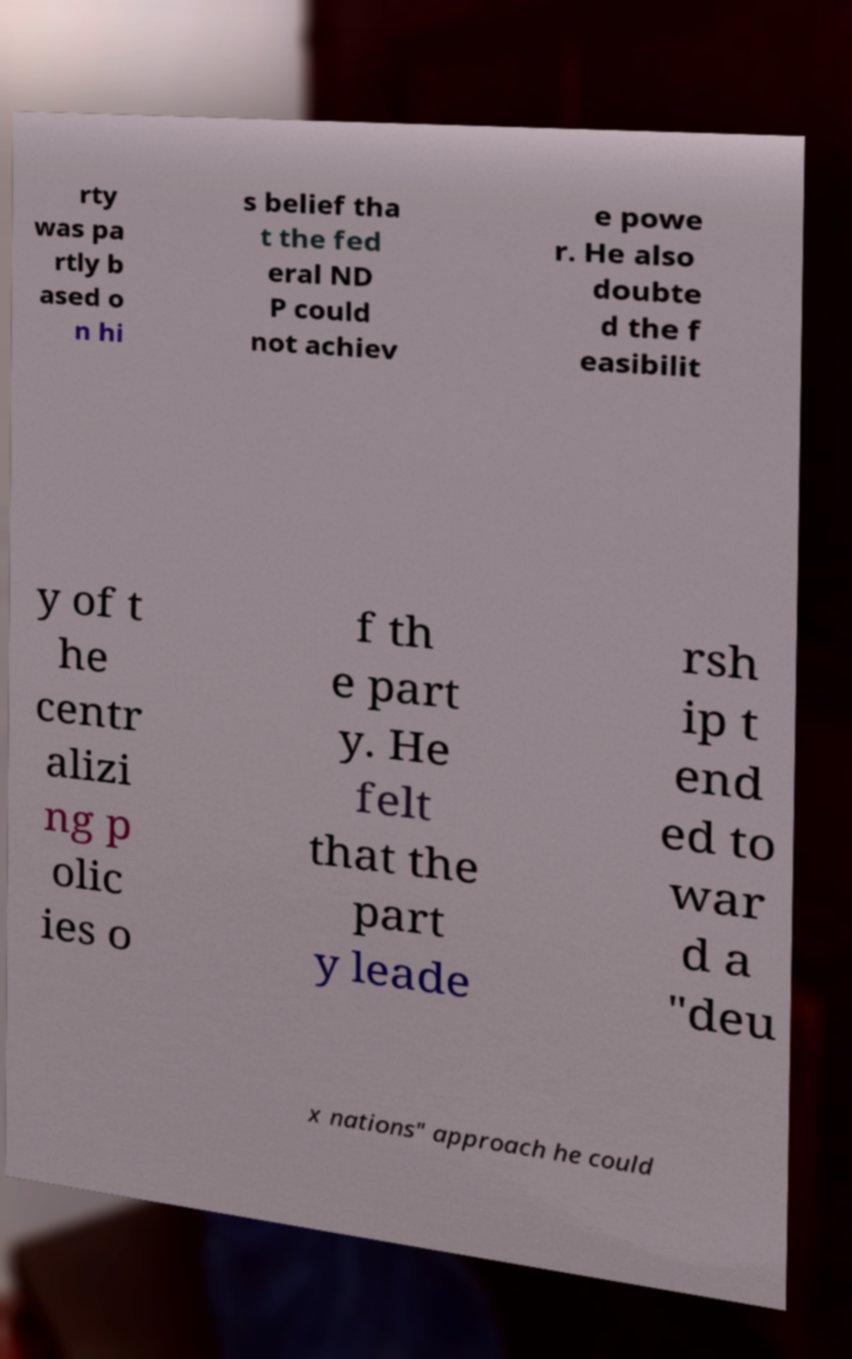Could you assist in decoding the text presented in this image and type it out clearly? rty was pa rtly b ased o n hi s belief tha t the fed eral ND P could not achiev e powe r. He also doubte d the f easibilit y of t he centr alizi ng p olic ies o f th e part y. He felt that the part y leade rsh ip t end ed to war d a "deu x nations" approach he could 